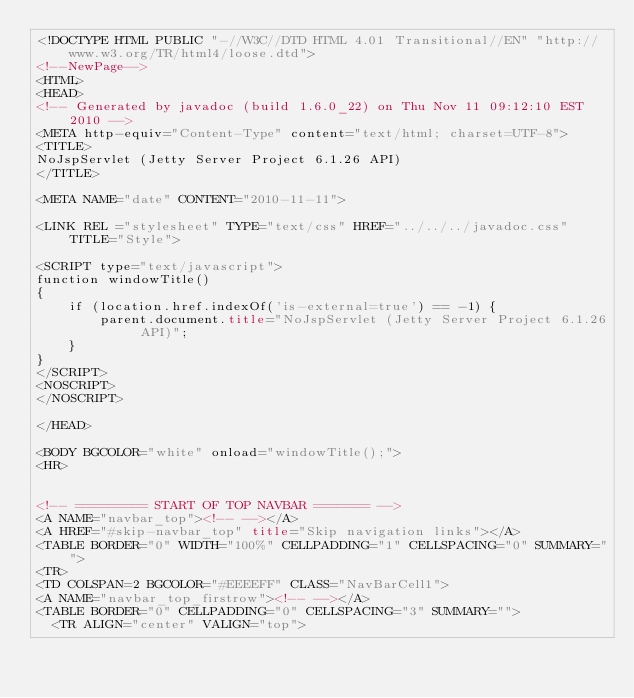<code> <loc_0><loc_0><loc_500><loc_500><_HTML_><!DOCTYPE HTML PUBLIC "-//W3C//DTD HTML 4.01 Transitional//EN" "http://www.w3.org/TR/html4/loose.dtd">
<!--NewPage-->
<HTML>
<HEAD>
<!-- Generated by javadoc (build 1.6.0_22) on Thu Nov 11 09:12:10 EST 2010 -->
<META http-equiv="Content-Type" content="text/html; charset=UTF-8">
<TITLE>
NoJspServlet (Jetty Server Project 6.1.26 API)
</TITLE>

<META NAME="date" CONTENT="2010-11-11">

<LINK REL ="stylesheet" TYPE="text/css" HREF="../../../javadoc.css" TITLE="Style">

<SCRIPT type="text/javascript">
function windowTitle()
{
    if (location.href.indexOf('is-external=true') == -1) {
        parent.document.title="NoJspServlet (Jetty Server Project 6.1.26 API)";
    }
}
</SCRIPT>
<NOSCRIPT>
</NOSCRIPT>

</HEAD>

<BODY BGCOLOR="white" onload="windowTitle();">
<HR>


<!-- ========= START OF TOP NAVBAR ======= -->
<A NAME="navbar_top"><!-- --></A>
<A HREF="#skip-navbar_top" title="Skip navigation links"></A>
<TABLE BORDER="0" WIDTH="100%" CELLPADDING="1" CELLSPACING="0" SUMMARY="">
<TR>
<TD COLSPAN=2 BGCOLOR="#EEEEFF" CLASS="NavBarCell1">
<A NAME="navbar_top_firstrow"><!-- --></A>
<TABLE BORDER="0" CELLPADDING="0" CELLSPACING="3" SUMMARY="">
  <TR ALIGN="center" VALIGN="top"></code> 